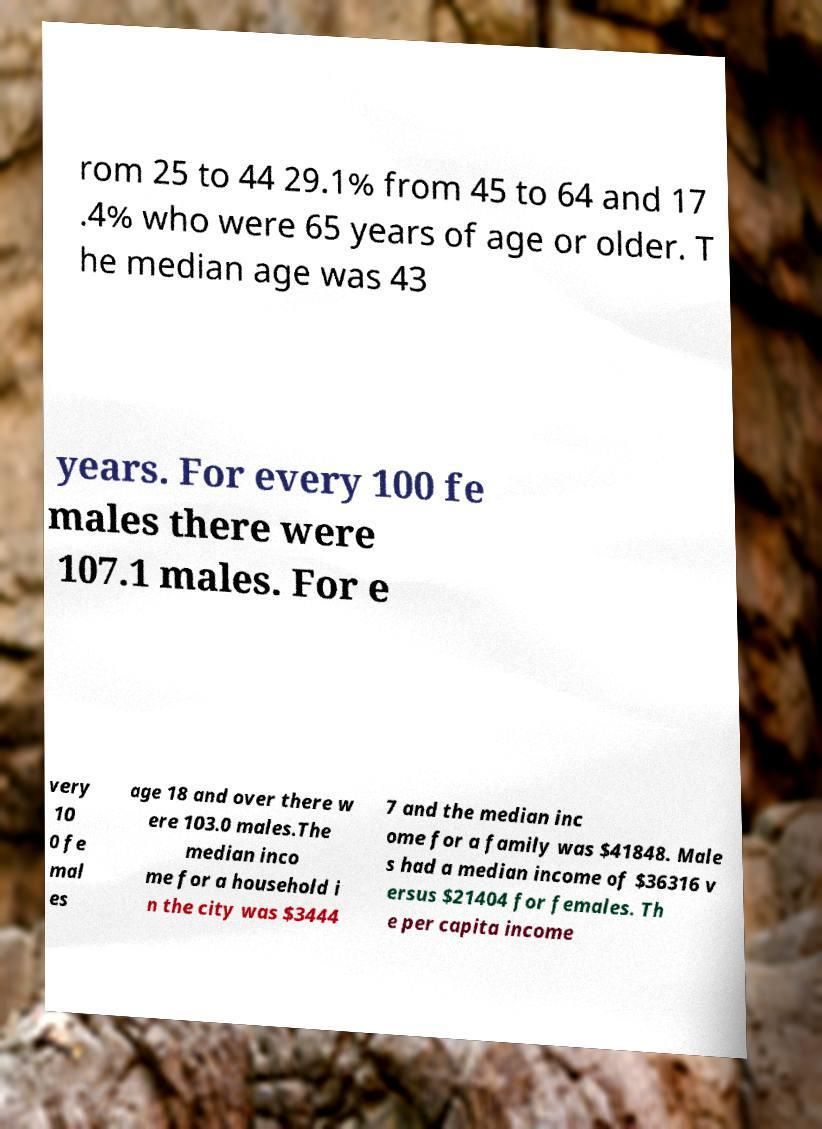For documentation purposes, I need the text within this image transcribed. Could you provide that? rom 25 to 44 29.1% from 45 to 64 and 17 .4% who were 65 years of age or older. T he median age was 43 years. For every 100 fe males there were 107.1 males. For e very 10 0 fe mal es age 18 and over there w ere 103.0 males.The median inco me for a household i n the city was $3444 7 and the median inc ome for a family was $41848. Male s had a median income of $36316 v ersus $21404 for females. Th e per capita income 